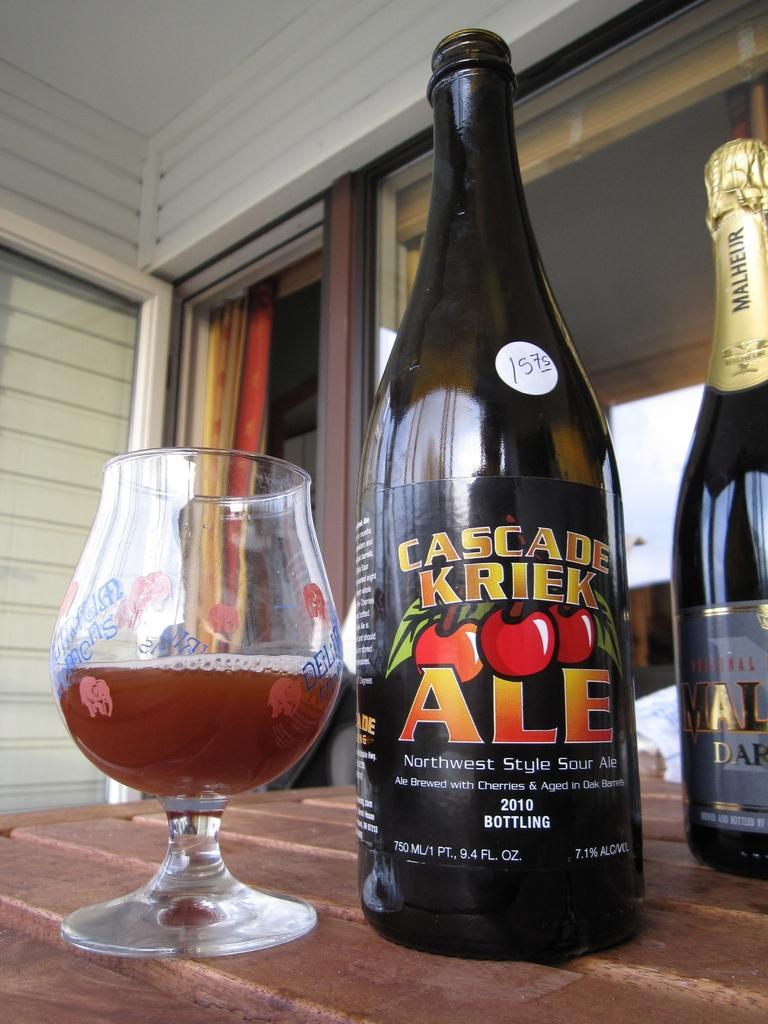<image>
Present a compact description of the photo's key features. A bottle of Cascade Kriek ale is next to a partially filled glass. 